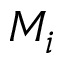Convert formula to latex. <formula><loc_0><loc_0><loc_500><loc_500>M _ { i }</formula> 